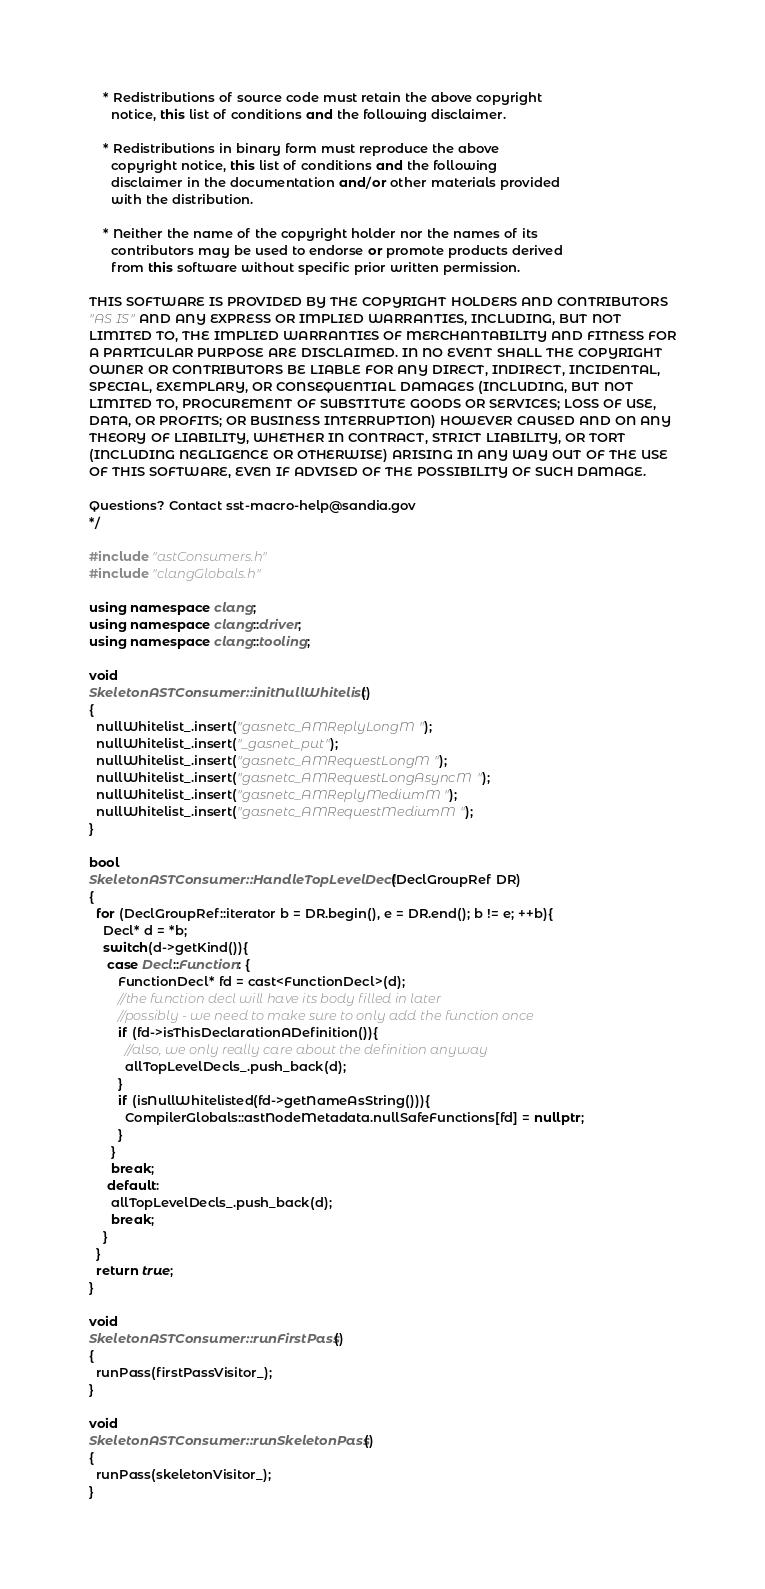Convert code to text. <code><loc_0><loc_0><loc_500><loc_500><_C++_>
    * Redistributions of source code must retain the above copyright
      notice, this list of conditions and the following disclaimer.

    * Redistributions in binary form must reproduce the above
      copyright notice, this list of conditions and the following
      disclaimer in the documentation and/or other materials provided
      with the distribution.

    * Neither the name of the copyright holder nor the names of its
      contributors may be used to endorse or promote products derived
      from this software without specific prior written permission.

THIS SOFTWARE IS PROVIDED BY THE COPYRIGHT HOLDERS AND CONTRIBUTORS
"AS IS" AND ANY EXPRESS OR IMPLIED WARRANTIES, INCLUDING, BUT NOT
LIMITED TO, THE IMPLIED WARRANTIES OF MERCHANTABILITY AND FITNESS FOR
A PARTICULAR PURPOSE ARE DISCLAIMED. IN NO EVENT SHALL THE COPYRIGHT
OWNER OR CONTRIBUTORS BE LIABLE FOR ANY DIRECT, INDIRECT, INCIDENTAL,
SPECIAL, EXEMPLARY, OR CONSEQUENTIAL DAMAGES (INCLUDING, BUT NOT
LIMITED TO, PROCUREMENT OF SUBSTITUTE GOODS OR SERVICES; LOSS OF USE,
DATA, OR PROFITS; OR BUSINESS INTERRUPTION) HOWEVER CAUSED AND ON ANY
THEORY OF LIABILITY, WHETHER IN CONTRACT, STRICT LIABILITY, OR TORT
(INCLUDING NEGLIGENCE OR OTHERWISE) ARISING IN ANY WAY OUT OF THE USE
OF THIS SOFTWARE, EVEN IF ADVISED OF THE POSSIBILITY OF SUCH DAMAGE.

Questions? Contact sst-macro-help@sandia.gov
*/

#include "astConsumers.h"
#include "clangGlobals.h"

using namespace clang;
using namespace clang::driver;
using namespace clang::tooling;

void
SkeletonASTConsumer::initNullWhitelist()
{
  nullWhitelist_.insert("gasnetc_AMReplyLongM");
  nullWhitelist_.insert("_gasnet_put");
  nullWhitelist_.insert("gasnetc_AMRequestLongM");
  nullWhitelist_.insert("gasnetc_AMRequestLongAsyncM");
  nullWhitelist_.insert("gasnetc_AMReplyMediumM");
  nullWhitelist_.insert("gasnetc_AMRequestMediumM");
}

bool
SkeletonASTConsumer::HandleTopLevelDecl(DeclGroupRef DR)
{
  for (DeclGroupRef::iterator b = DR.begin(), e = DR.end(); b != e; ++b){
    Decl* d = *b;
    switch(d->getKind()){
     case Decl::Function: {
        FunctionDecl* fd = cast<FunctionDecl>(d);
        //the function decl will have its body filled in later
        //possibly - we need to make sure to only add the function once
        if (fd->isThisDeclarationADefinition()){
          //also, we only really care about the definition anyway
          allTopLevelDecls_.push_back(d);
        }
        if (isNullWhitelisted(fd->getNameAsString())){
          CompilerGlobals::astNodeMetadata.nullSafeFunctions[fd] = nullptr;
        }
      }
      break;
     default:
      allTopLevelDecls_.push_back(d);
      break;
    }
  }
  return true;
}

void
SkeletonASTConsumer::runFirstPass()
{
  runPass(firstPassVisitor_);
}

void
SkeletonASTConsumer::runSkeletonPass()
{
  runPass(skeletonVisitor_);
}
</code> 